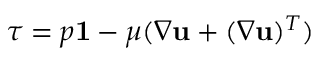Convert formula to latex. <formula><loc_0><loc_0><loc_500><loc_500>\tau = p 1 - \mu ( \nabla u + ( \nabla u ) ^ { T } )</formula> 